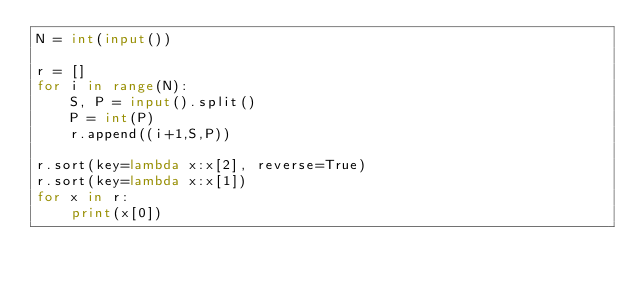<code> <loc_0><loc_0><loc_500><loc_500><_Python_>N = int(input())

r = []
for i in range(N):
    S, P = input().split()
    P = int(P)
    r.append((i+1,S,P))

r.sort(key=lambda x:x[2], reverse=True)
r.sort(key=lambda x:x[1])
for x in r:
    print(x[0])
</code> 